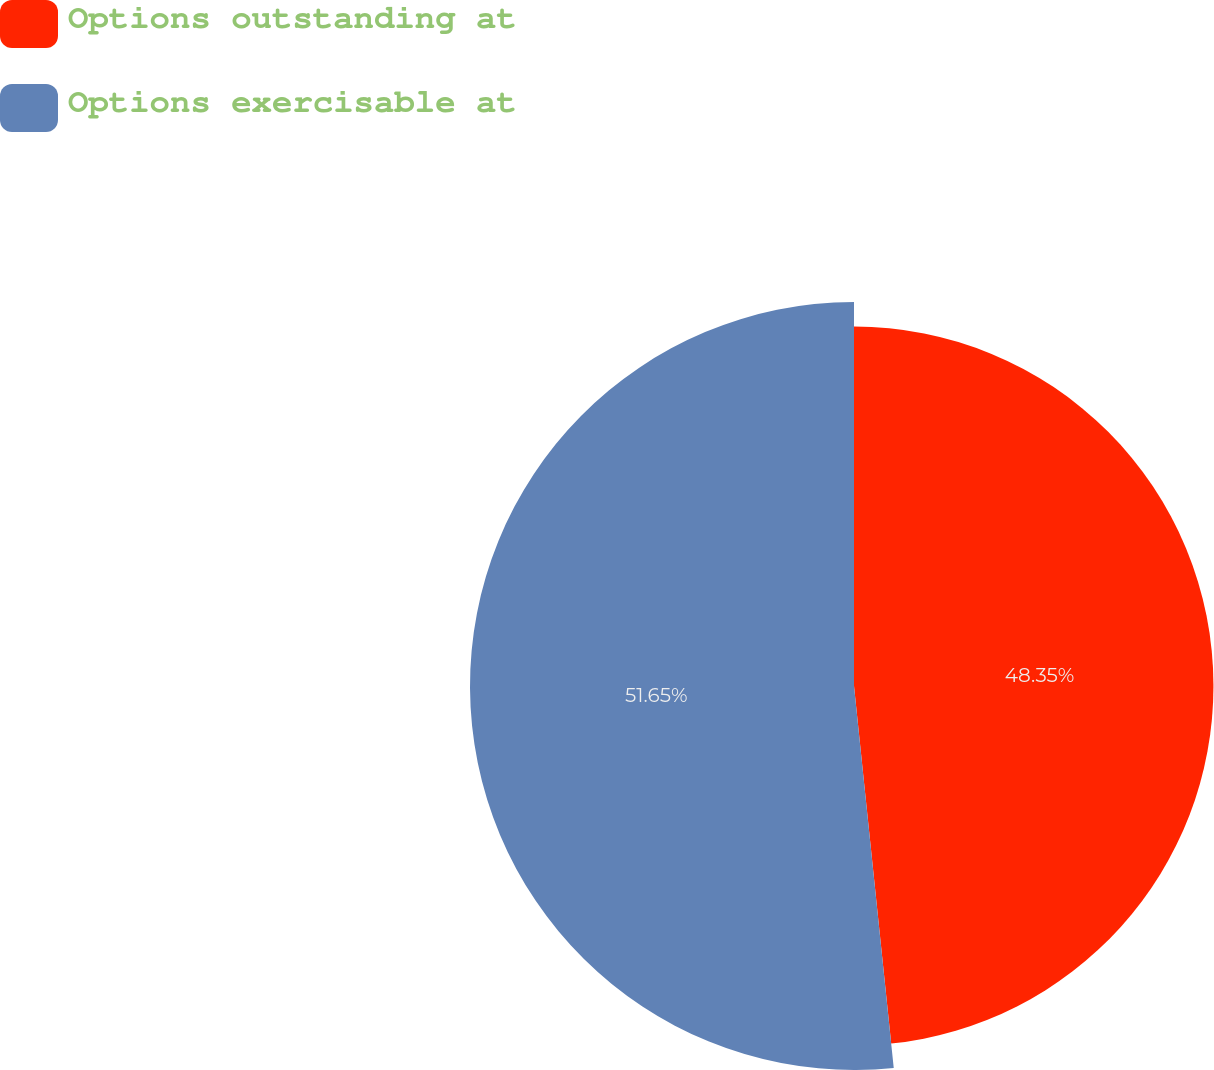Convert chart. <chart><loc_0><loc_0><loc_500><loc_500><pie_chart><fcel>Options outstanding at<fcel>Options exercisable at<nl><fcel>48.35%<fcel>51.65%<nl></chart> 